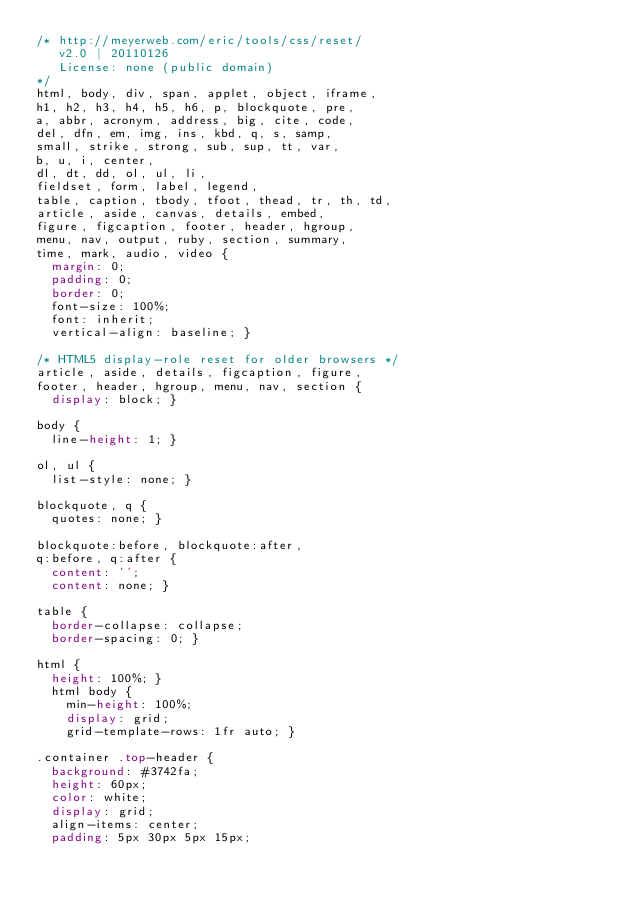Convert code to text. <code><loc_0><loc_0><loc_500><loc_500><_CSS_>/* http://meyerweb.com/eric/tools/css/reset/ 
   v2.0 | 20110126
   License: none (public domain)
*/
html, body, div, span, applet, object, iframe,
h1, h2, h3, h4, h5, h6, p, blockquote, pre,
a, abbr, acronym, address, big, cite, code,
del, dfn, em, img, ins, kbd, q, s, samp,
small, strike, strong, sub, sup, tt, var,
b, u, i, center,
dl, dt, dd, ol, ul, li,
fieldset, form, label, legend,
table, caption, tbody, tfoot, thead, tr, th, td,
article, aside, canvas, details, embed,
figure, figcaption, footer, header, hgroup,
menu, nav, output, ruby, section, summary,
time, mark, audio, video {
  margin: 0;
  padding: 0;
  border: 0;
  font-size: 100%;
  font: inherit;
  vertical-align: baseline; }

/* HTML5 display-role reset for older browsers */
article, aside, details, figcaption, figure,
footer, header, hgroup, menu, nav, section {
  display: block; }

body {
  line-height: 1; }

ol, ul {
  list-style: none; }

blockquote, q {
  quotes: none; }

blockquote:before, blockquote:after,
q:before, q:after {
  content: '';
  content: none; }

table {
  border-collapse: collapse;
  border-spacing: 0; }

html {
  height: 100%; }
  html body {
    min-height: 100%;
    display: grid;
    grid-template-rows: 1fr auto; }

.container .top-header {
  background: #3742fa;
  height: 60px;
  color: white;
  display: grid;
  align-items: center;
  padding: 5px 30px 5px 15px;</code> 